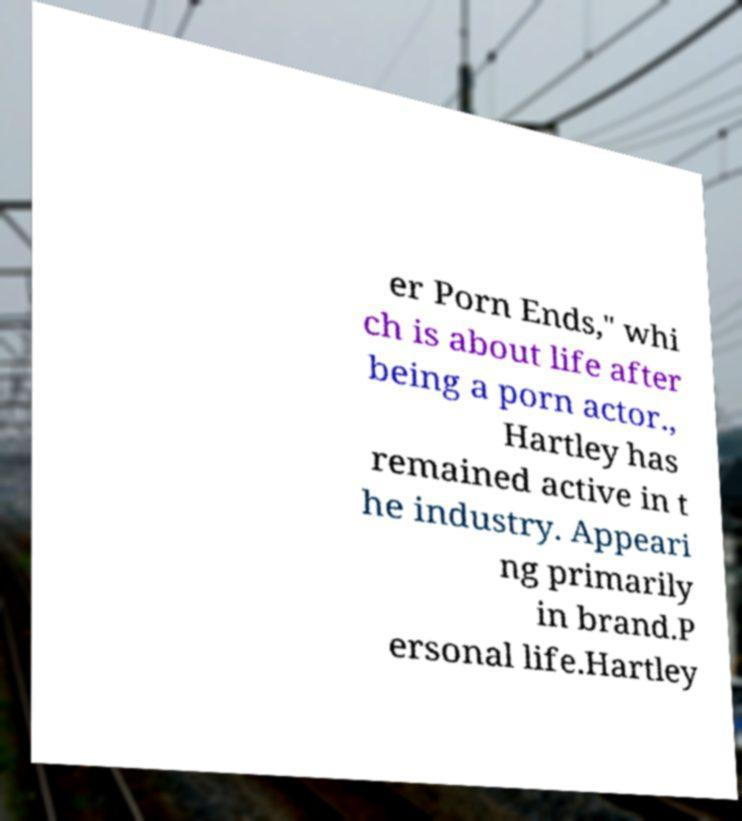Can you accurately transcribe the text from the provided image for me? er Porn Ends," whi ch is about life after being a porn actor., Hartley has remained active in t he industry. Appeari ng primarily in brand.P ersonal life.Hartley 